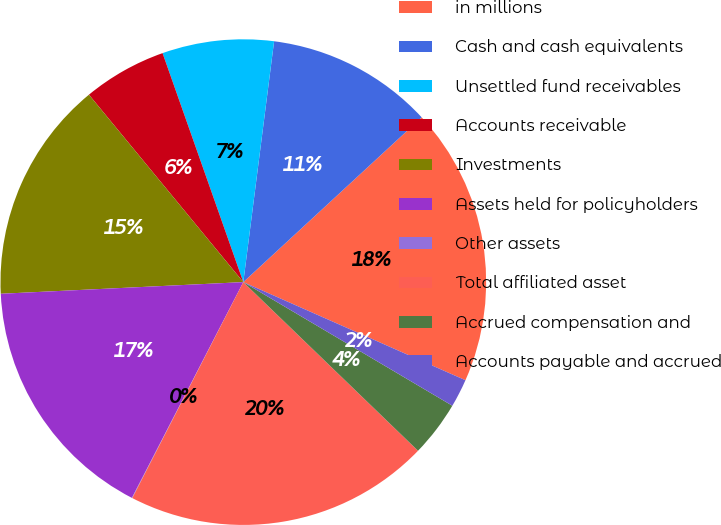<chart> <loc_0><loc_0><loc_500><loc_500><pie_chart><fcel>in millions<fcel>Cash and cash equivalents<fcel>Unsettled fund receivables<fcel>Accounts receivable<fcel>Investments<fcel>Assets held for policyholders<fcel>Other assets<fcel>Total affiliated asset<fcel>Accrued compensation and<fcel>Accounts payable and accrued<nl><fcel>18.49%<fcel>11.11%<fcel>7.42%<fcel>5.57%<fcel>14.8%<fcel>16.65%<fcel>0.03%<fcel>20.34%<fcel>3.72%<fcel>1.88%<nl></chart> 